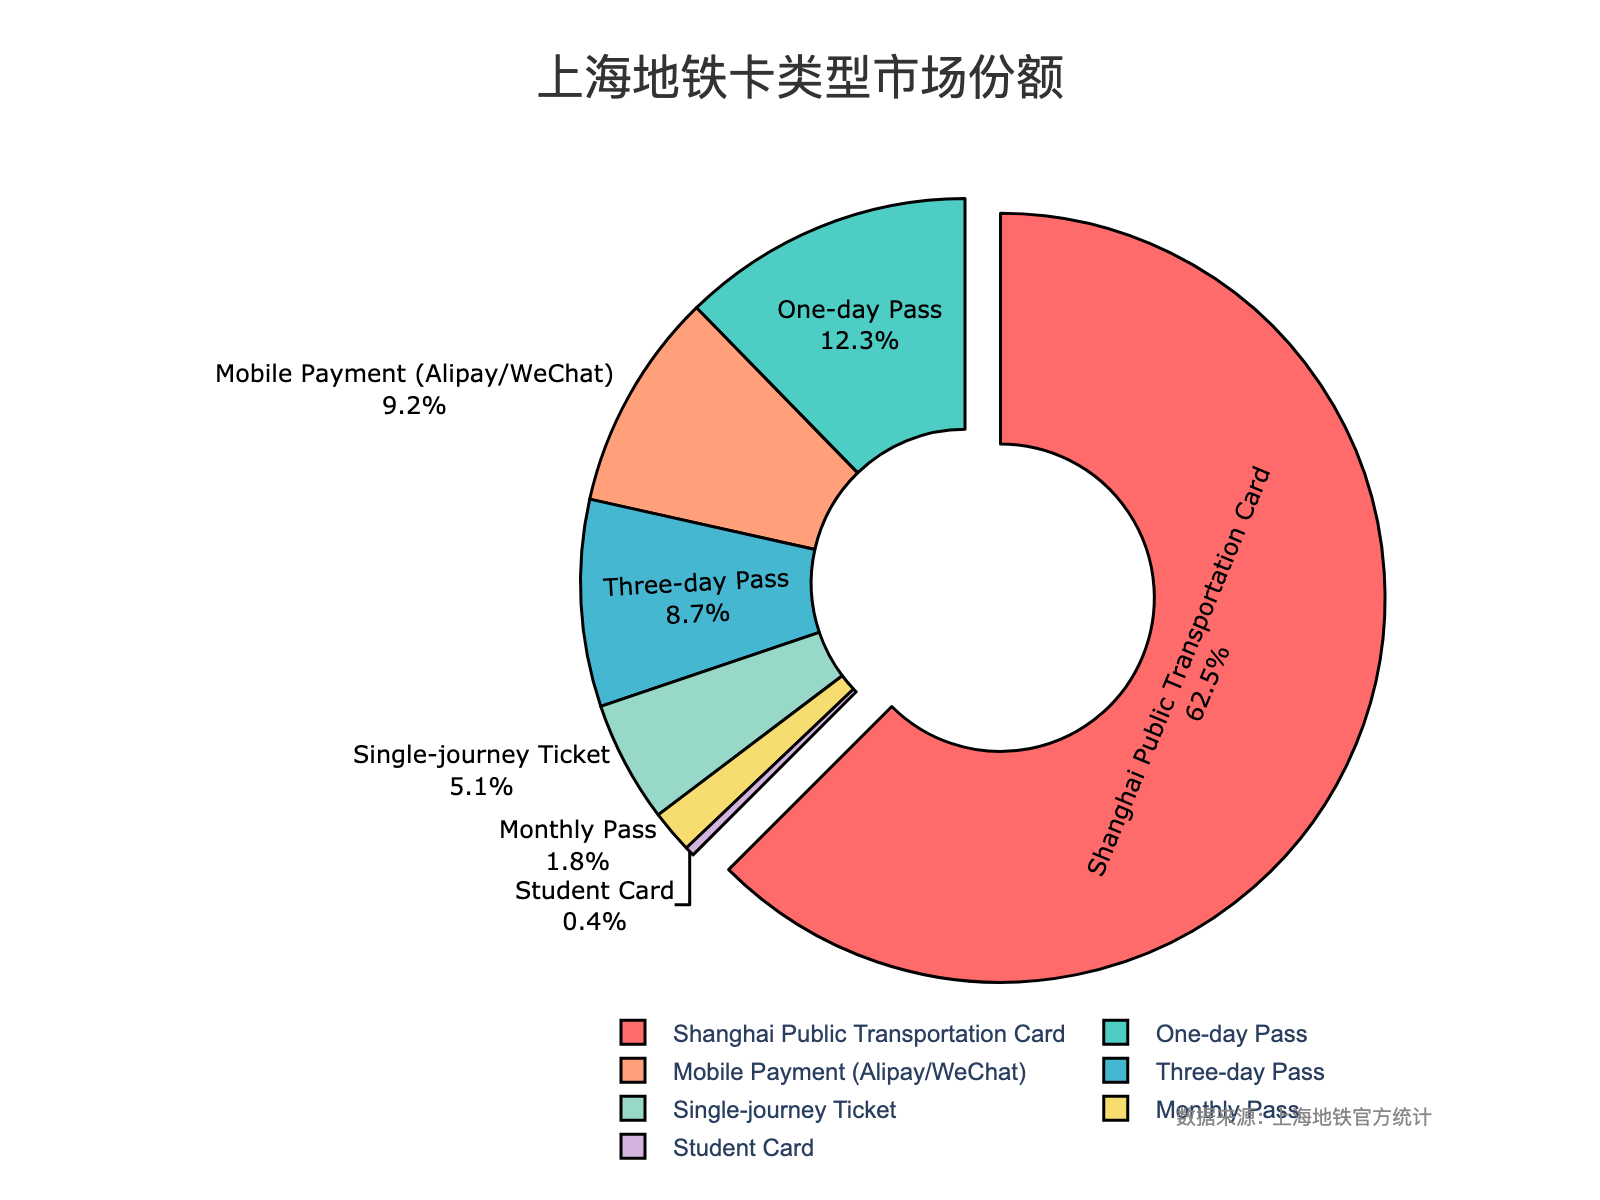What's the most popular metro card type? The largest section of the pie chart represents the Shanghai Public Transportation Card with the highest percentage.
Answer: Shanghai Public Transportation Card Which metro card type has the lowest market share? The smallest section of the pie chart is the Student Card, which has the smallest percentage.
Answer: Student Card How much more popular is the Shanghai Public Transportation Card compared to Single-journey Ticket? The Shanghai Public Transportation Card has a market share of 62.5%, and the Single-journey Ticket has 5.1%. The difference between them is 62.5% - 5.1% = 57.4%.
Answer: 57.4% What percentage of the market share is held by passes (One-day Pass and Three-day Pass) combined? The One-day Pass has a market share of 12.3%, and the Three-day Pass has 8.7%. Their combined market share is 12.3% + 8.7% = 21%.
Answer: 21% Do Mobile Payment methods (Alipay/WeChat) have a higher or lower market share compared to the One-day Pass? Mobile Payment has a market share of 9.2%, while the One-day Pass has 12.3%. Therefore, Mobile Payment has a lower market share.
Answer: Lower What's the combined market share of the three least popular metro card types? The least popular metro card types are Monthly Pass (1.8%), Student Card (0.4%), and Single-journey Ticket (5.1%). Their combined market share is 1.8% + 0.4% + 5.1% = 7.3%.
Answer: 7.3% Which card type is represented by the green colored section? From the color key provided, the green colored section represents the One-day Pass.
Answer: One-day Pass What is the combined market share of Shanghai Public Transportation Card and Mobile Payment? The Shanghai Public Transportation Card has a market share of 62.5%, and Mobile Payment has 9.2%. Their combined market share is 62.5% + 9.2% = 71.7%.
Answer: 71.7% Is the market share of One-day Pass more than double that of the Monthly Pass? The One-day Pass has a market share of 12.3%, and the Monthly Pass has 1.8%. Double the market share of Monthly Pass would be 1.8% * 2 = 3.6%, which is less than 12.3%. Therefore, the One-day Pass's market share is more than double.
Answer: Yes 